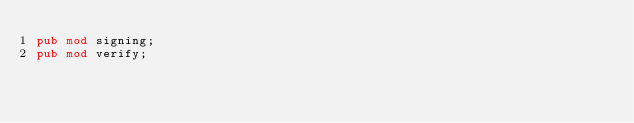Convert code to text. <code><loc_0><loc_0><loc_500><loc_500><_Rust_>pub mod signing;
pub mod verify;
</code> 